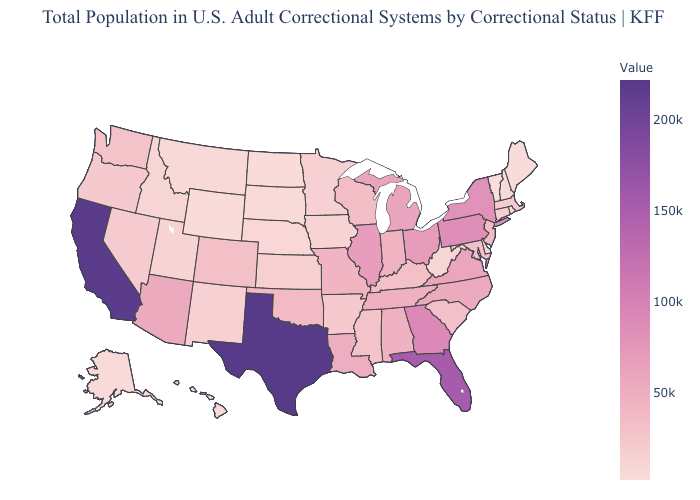Which states hav the highest value in the Northeast?
Quick response, please. Pennsylvania. Is the legend a continuous bar?
Keep it brief. Yes. Does the map have missing data?
Quick response, please. No. Does Nevada have a higher value than Louisiana?
Answer briefly. No. Does the map have missing data?
Keep it brief. No. 